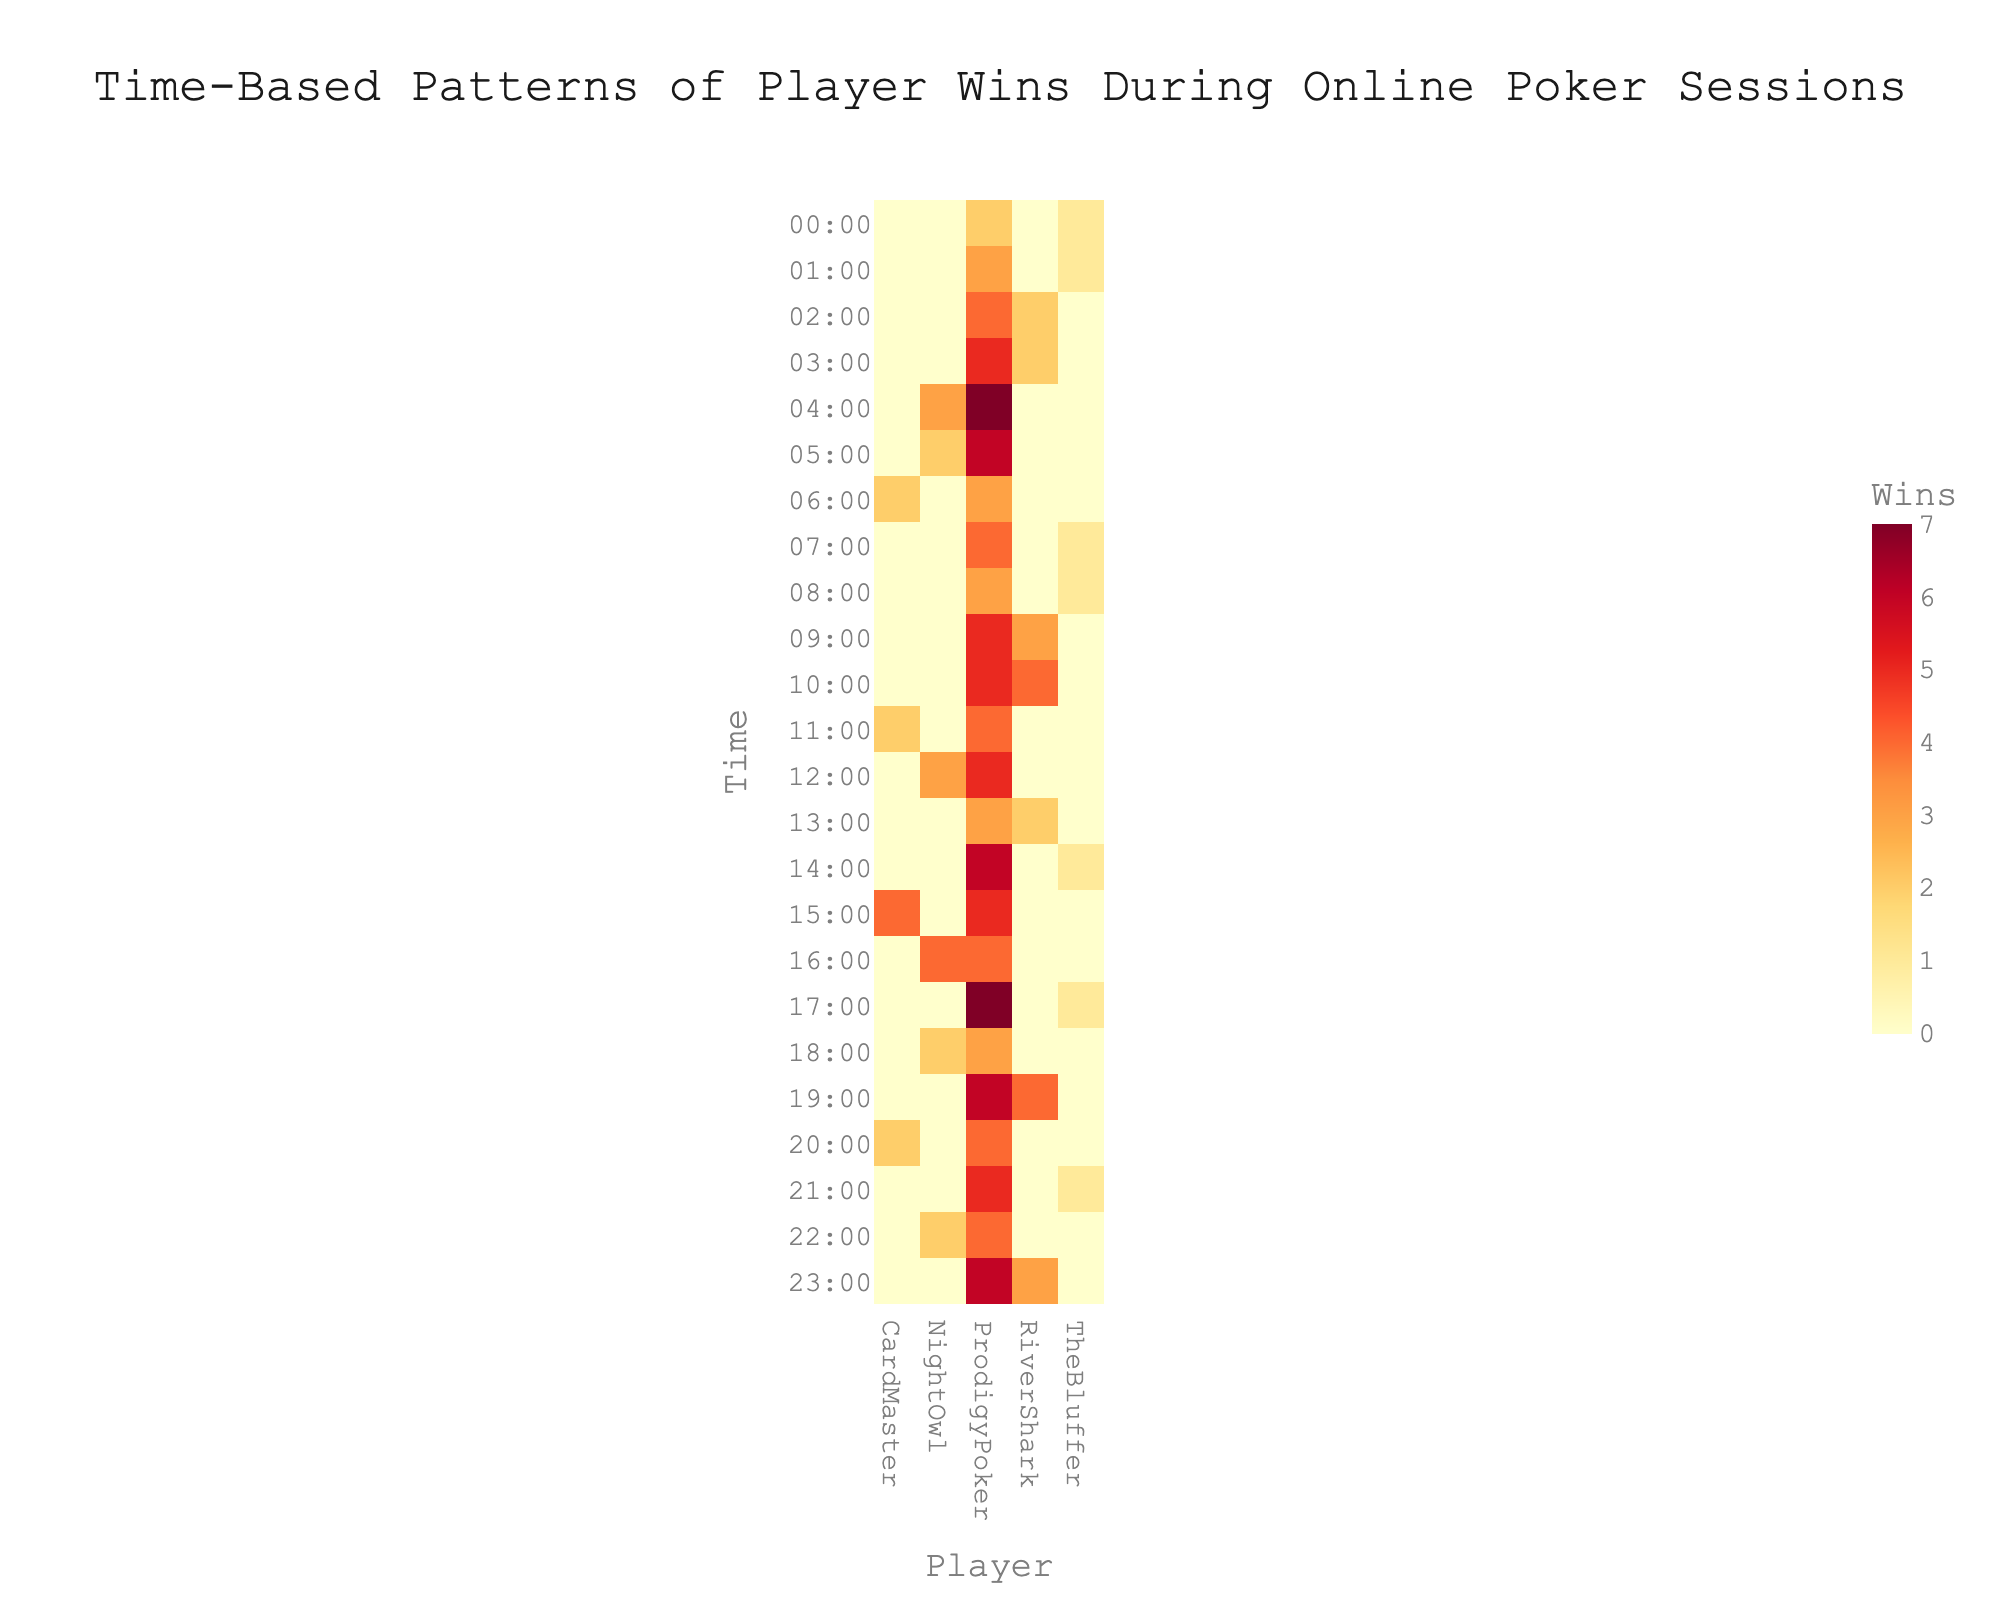What is the highest number of wins recorded by any player at any given time? Look at the heatmap to identify the maximum value in the color scale, which represents the number of wins. The darkest or most intense color usually indicates this maximum value. Based on the data, the highest number of wins is 7.
Answer: 7 At what times does ProdigyPoker win the most games? Check the heatmap for the rows corresponding to 'ProdigyPoker' and observe the times with the darkest color, which represents the highest wins. ProdigyPoker wins the most games with 7 wins at 04:00 and 17:00.
Answer: 04:00 and 17:00 Who has the least number of wins in total, based on the heatmap? Sum the values across all times for each player in the heatmap to identify the player with the lowest total wins. TheBluffer has the lowest total wins, consistently showing low-intensity colors.
Answer: TheBluffer How many total wins does RiverShark have between 19:00 and 23:00? Identify the rows corresponding to 'RiverShark' and sum the values between 19:00 and 23:00. The values are 4 (19:00), 3 (23:00), and nothing for 22:00, totaling 7 wins.
Answer: 7 How do ProdigyPoker's wins between 00:00 and 12:00 compare to their wins between 12:00 and 23:00? Sum the wins for ProdigyPoker from 00:00 to 12:00 and from 13:00 to 23:00 separately, then compare the two sums. From 00:00 to 12:00, the sum is 54. From 12:00 to 23:00, the sum is 60. Therefore, ProdigyPoker has more wins in the latter period.
Answer: More wins from 12:00 to 23:00 Which player has the most consistent number of wins across different times? Analyze the heatmap to identify the player whose win counts show the least variance in color intensity across different times. NightOwl shows a relatively consistent number of wins at different times, clustered around moderate win counts.
Answer: NightOwl During which hour does NightOwl achieve their highest number of wins? Locate the row labeled 'NightOwl' in the heatmap and identify the time with the darkest color, which indicates the highest wins. NightOwl achieves their highest number of wins (4) at 16:00.
Answer: 16:00 Compare the patterns of wins between ProdigyPoker and TheBluffer. What stands out? Examine the heatmap rows for 'ProdigyPoker' and 'TheBluffer' to observe the differences in color intensity patterns. ProdigyPoker generally has darker colors showing higher wins, while TheBluffer consistently has lighter colors indicating lower wins.
Answer: ProdigyPoker has higher wins At what time do both ProdigyPoker and RiverShark have equal wins? Locate the times at which both 'ProdigyPoker' and 'RiverShark' have the same value in the heatmap. Both players have equal wins (4) at 02:00.
Answer: 02:00 